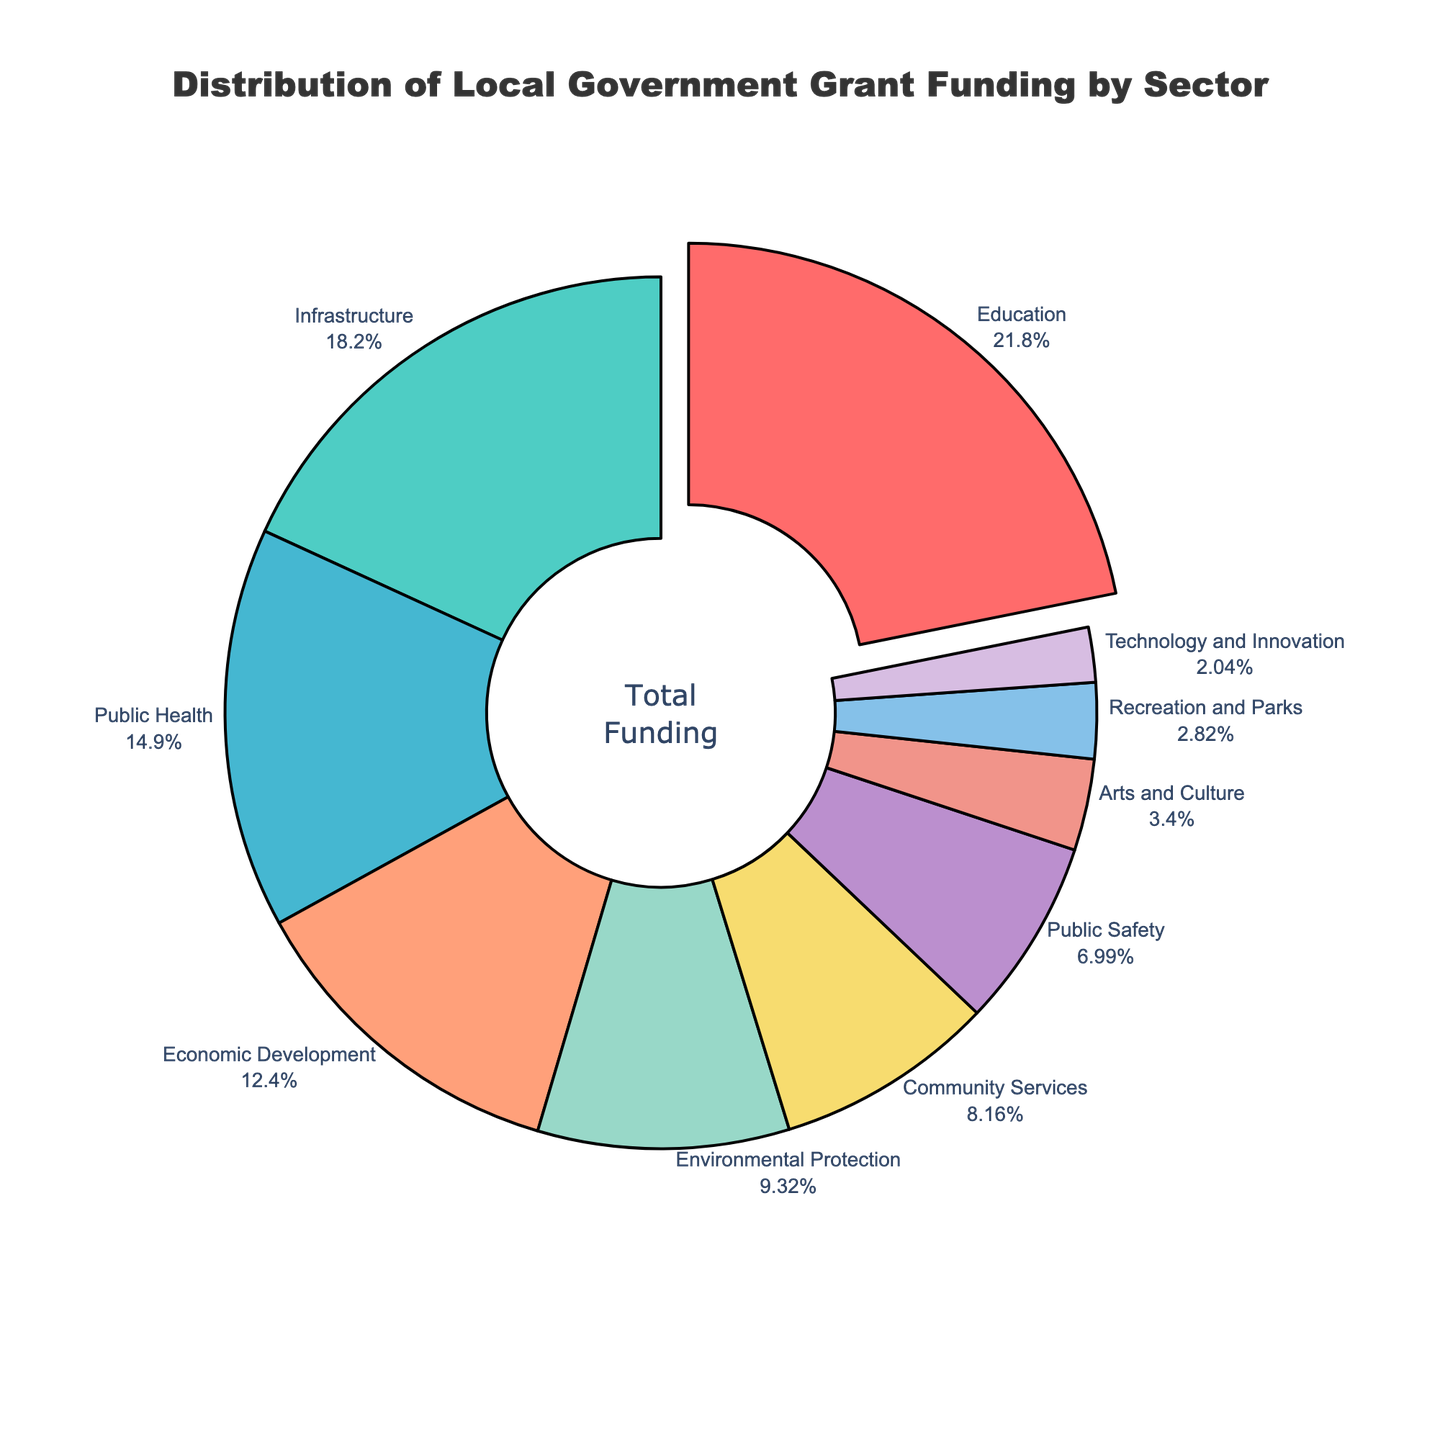What sector receives the largest share of the local government grant funding? The largest portion is indicated by the segment that has been slightly pulled out from the pie chart. This sector is "Education" with a funding percentage of 22.5%.
Answer: Education What sectors make up more than 10% of the funding each? To find these sectors, observe the labels on the pie chart and identify the ones where the percentage is greater than 10%. These are "Education" (22.5%), "Infrastructure" (18.7%), "Public Health" (15.3%), and "Economic Development" (12.8%).
Answer: Education, Infrastructure, Public Health, Economic Development On average, how much funding is allocated to "Recreation and Parks" and "Technology and Innovation"? Add the percentages of both sectors and then divide by 2. (2.9% + 2.1%) / 2 = 2.5%.
Answer: 2.5% How much more funding does "Education" receive than "Public Safety"? Subtract the percentage allocated to "Public Safety" from that allocated to "Education". 22.5% - 7.2% = 15.3%.
Answer: 15.3% Which has more funding, "Environmental Protection" or "Community Services", and by how much? Compare the percentages directly. "Environmental Protection" (9.6%) - "Community Services" (8.4%) = 1.2%.
Answer: Environmental Protection by 1.2% What is the combined funding percentage for "Arts and Culture" and "Recreation and Parks"? Add the percentages for both sectors. 3.5% + 2.9% = 6.4%.
Answer: 6.4% Rank the top three sectors by funding from highest to lowest. Examine the pie chart labels to identify the top three percentages: 1. Education (22.5%), 2. Infrastructure (18.7%), and 3. Public Health (15.3%).
Answer: 1. Education, 2. Infrastructure, 3. Public Health Which sector receives the least amount of funding and what percentage is it? Identify the smallest segment in the pie chart, which corresponds to "Technology and Innovation" with 2.1%.
Answer: Technology and Innovation, 2.1% If you combine the funding for "Public Safety" and "Arts and Culture", what fraction of the total funding do they represent? Add the percentages and express them as a fraction of 100. (7.2% + 3.5%) = 10.7%, which is 10.7/100 or 10.7%.
Answer: 10.7% 